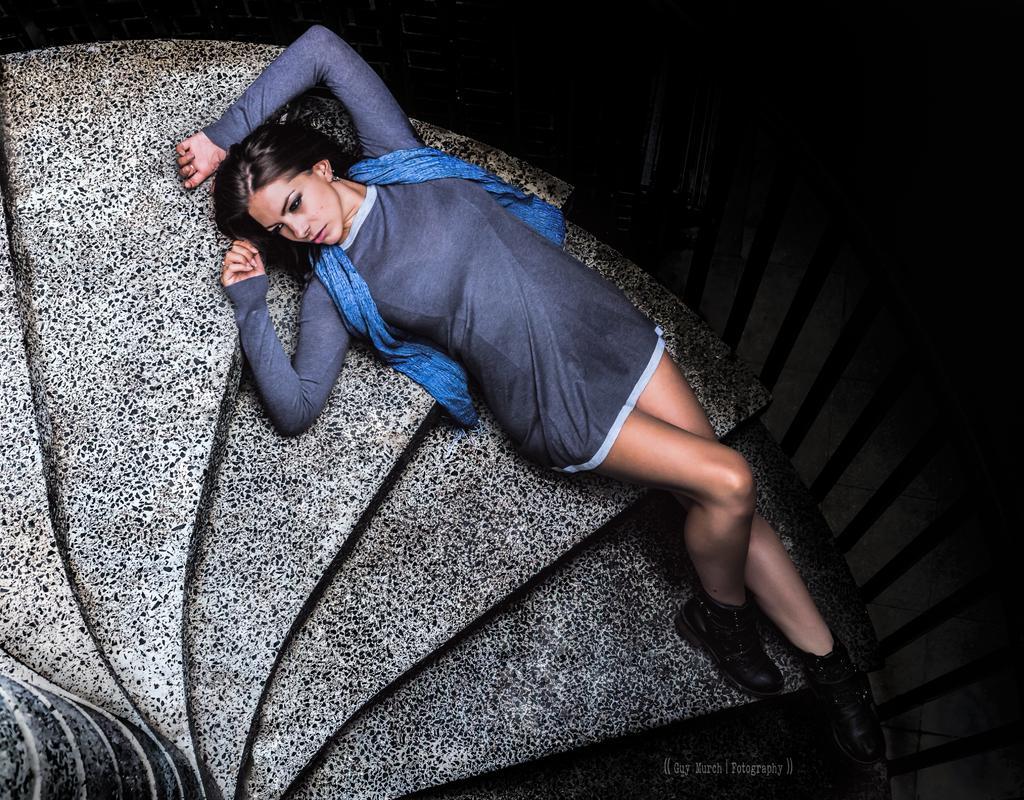How would you summarize this image in a sentence or two? In this image, we can see a woman lying on the stairs. On the right side of the image, we can see the railing and dark view. At the bottom of the image, there is a watermark. 